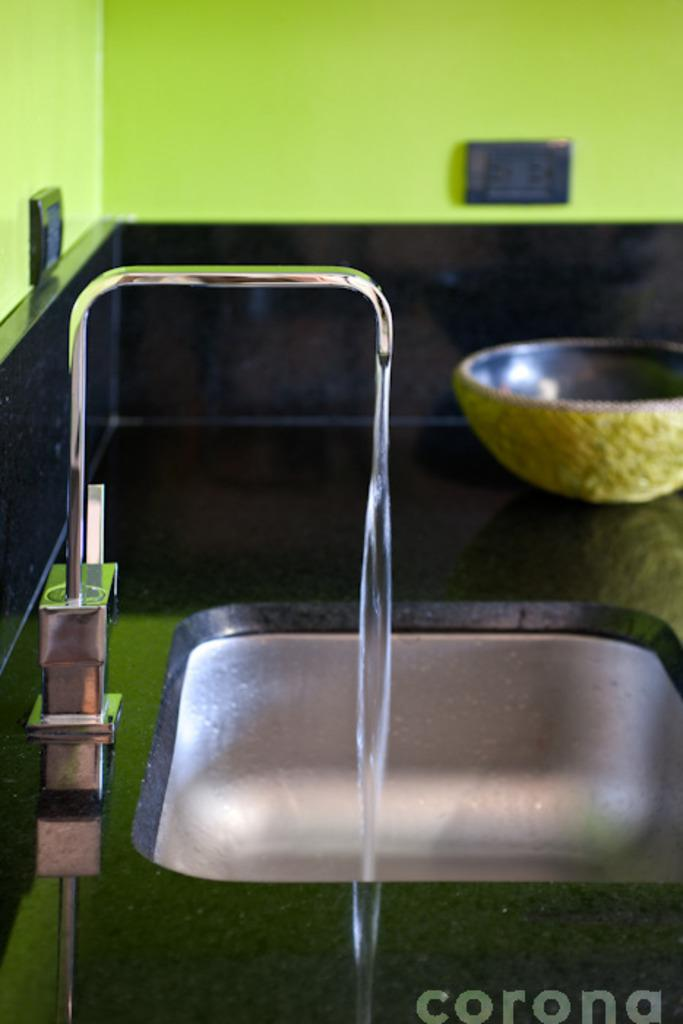What can be found in the image that is used for washing or cleaning? There is a sink with a tap in the image. What is present in the sink? Water is visible in the sink. What object is placed near the sink? There is a bowl placed aside in the image. What type of electrical components can be seen in the image? There are switch boards on a wall in the image. What type of bird can be seen flying near the airport in the image? There is no airport or bird present in the image. What type of structure is visible in the image? The image does not show any specific structure; it only contains a sink, water, a bowl, and switch boards. 